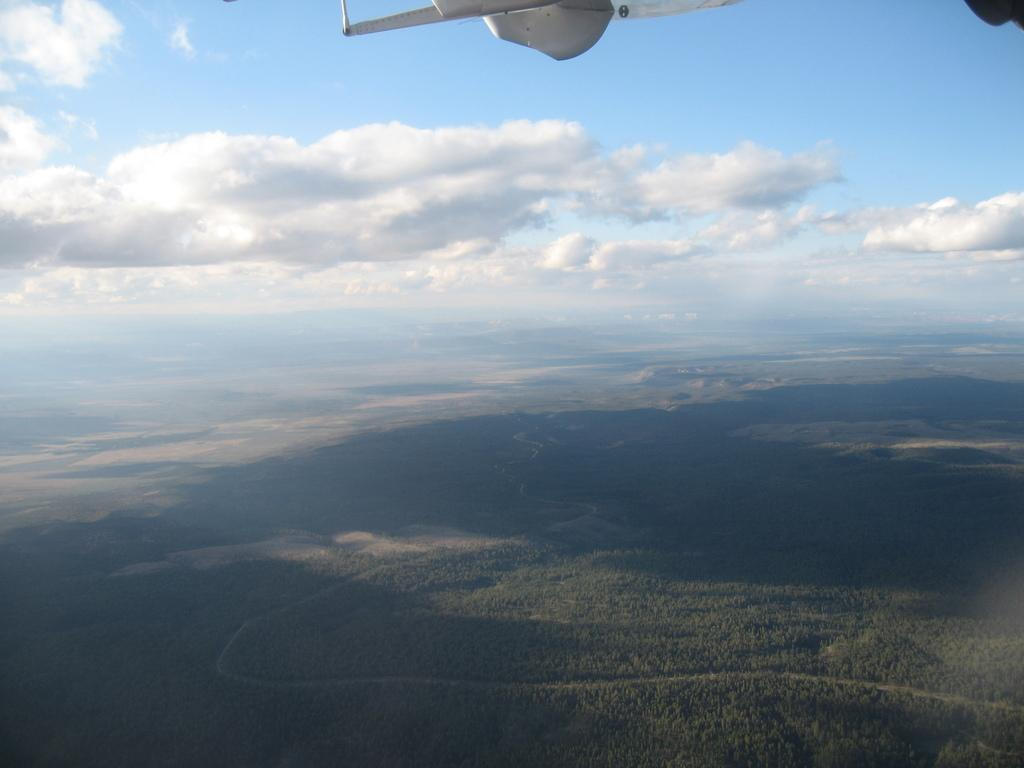What is located at the bottom of the image? There are trees and mountains at the bottom of the image. What is the main subject of the image? The main subject of the image is an airplane. Where is the airplane located in the image? The airplane is at the top of the image. What can be seen in the background of the image? The sky is visible in the background of the image. What type of potato is being used as an apparatus in the image? There is no potato or apparatus present in the image. Can you describe the attack being carried out by the airplane in the image? There is no attack being carried out by the airplane in the image; it is simply flying in the sky. 